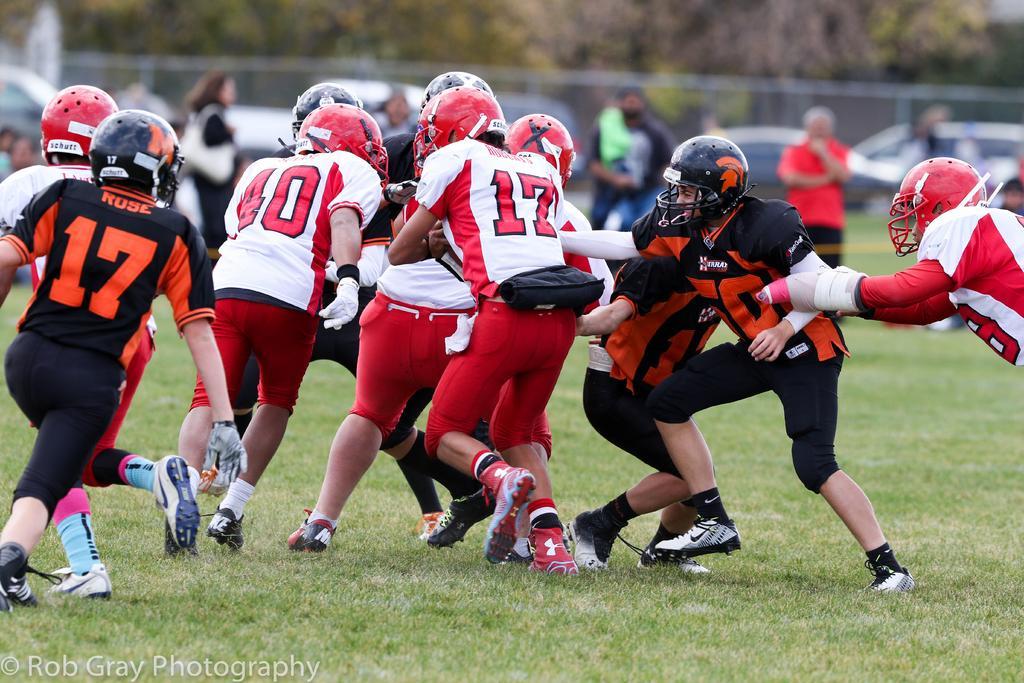Can you describe this image briefly? In this image, we can see a group of people playing a game on the grass. In the background, we can see the blur view, people, vehicles, some objects and trees. In the bottom left corner, there is a watermark. 